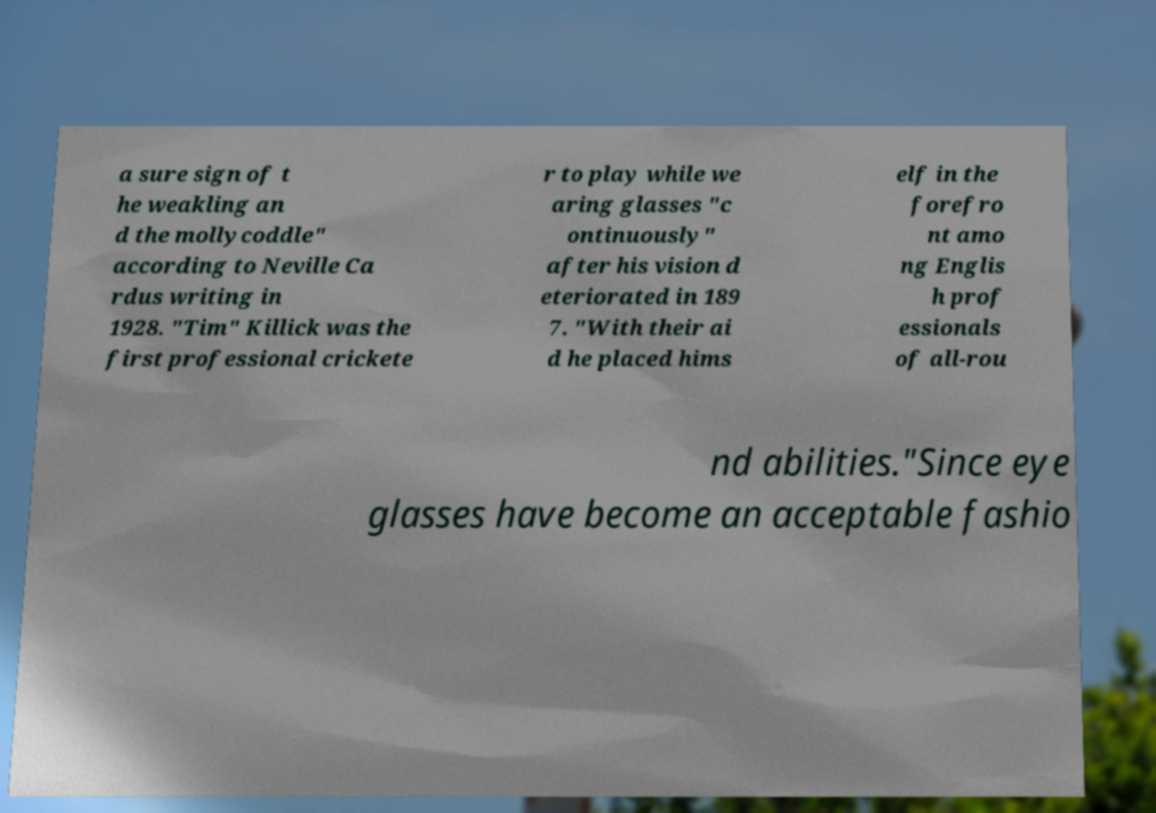There's text embedded in this image that I need extracted. Can you transcribe it verbatim? a sure sign of t he weakling an d the mollycoddle" according to Neville Ca rdus writing in 1928. "Tim" Killick was the first professional crickete r to play while we aring glasses "c ontinuously" after his vision d eteriorated in 189 7. "With their ai d he placed hims elf in the forefro nt amo ng Englis h prof essionals of all-rou nd abilities."Since eye glasses have become an acceptable fashio 